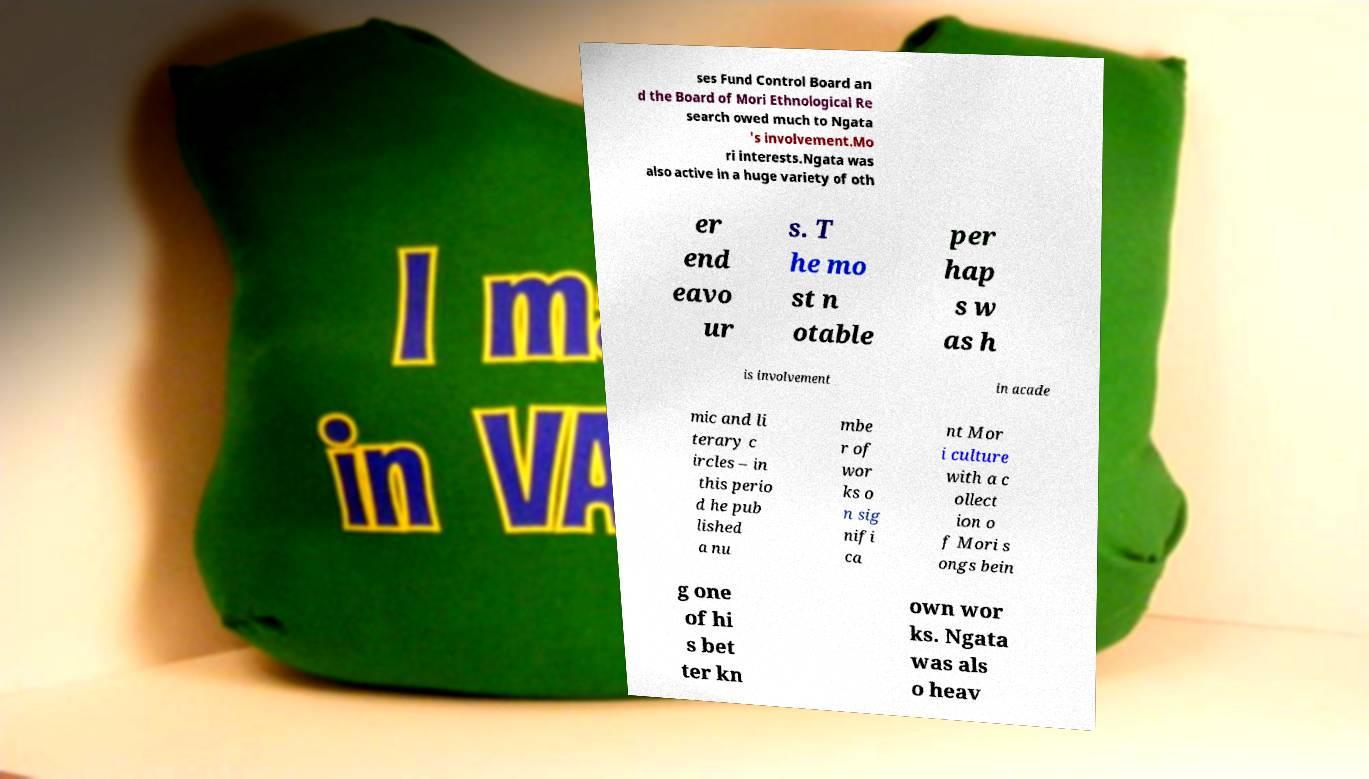For documentation purposes, I need the text within this image transcribed. Could you provide that? ses Fund Control Board an d the Board of Mori Ethnological Re search owed much to Ngata 's involvement.Mo ri interests.Ngata was also active in a huge variety of oth er end eavo ur s. T he mo st n otable per hap s w as h is involvement in acade mic and li terary c ircles – in this perio d he pub lished a nu mbe r of wor ks o n sig nifi ca nt Mor i culture with a c ollect ion o f Mori s ongs bein g one of hi s bet ter kn own wor ks. Ngata was als o heav 